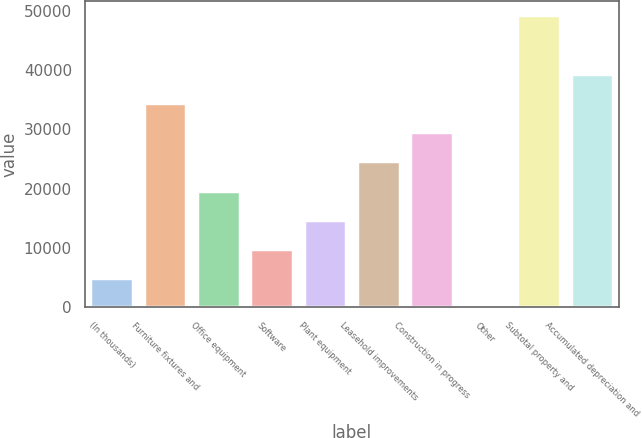Convert chart to OTSL. <chart><loc_0><loc_0><loc_500><loc_500><bar_chart><fcel>(In thousands)<fcel>Furniture fixtures and<fcel>Office equipment<fcel>Software<fcel>Plant equipment<fcel>Leasehold improvements<fcel>Construction in progress<fcel>Other<fcel>Subtotal property and<fcel>Accumulated depreciation and<nl><fcel>4943.2<fcel>34458.4<fcel>19700.8<fcel>9862.4<fcel>14781.6<fcel>24620<fcel>29539.2<fcel>24<fcel>49216<fcel>39377.6<nl></chart> 